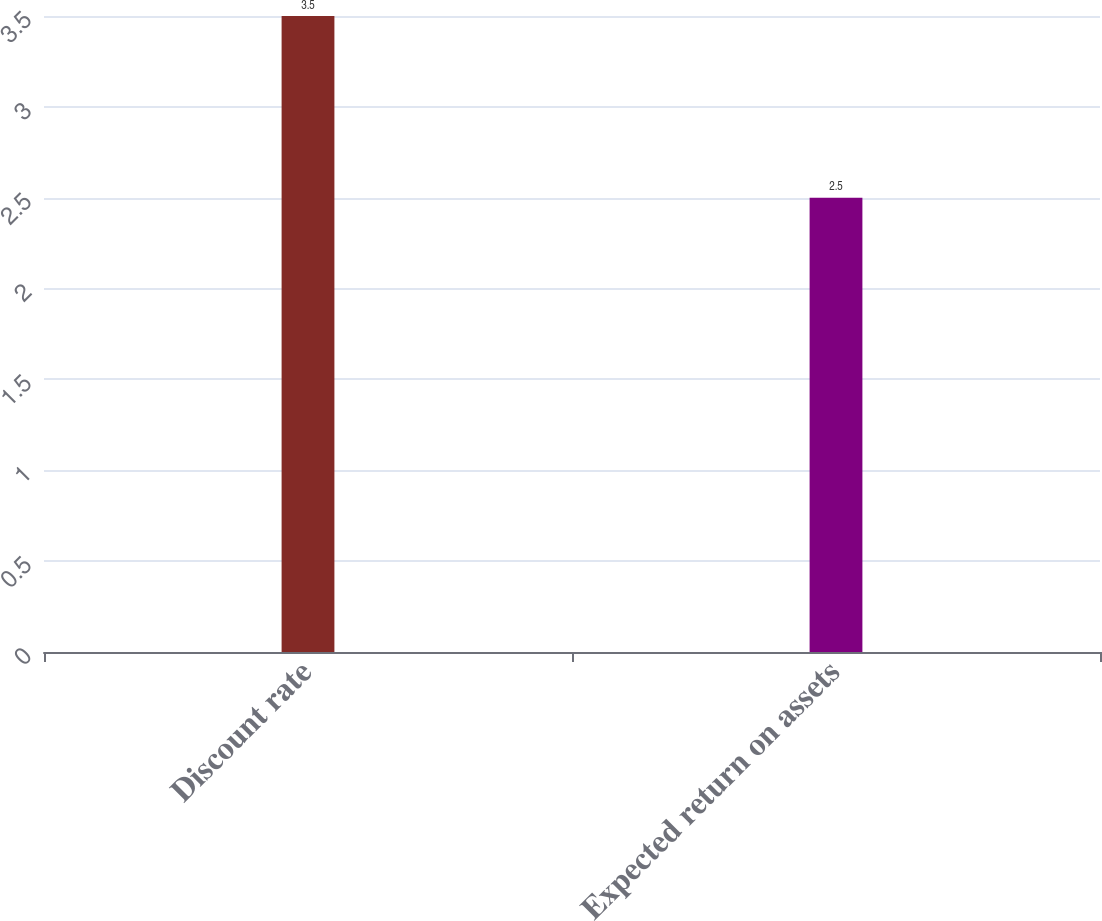Convert chart to OTSL. <chart><loc_0><loc_0><loc_500><loc_500><bar_chart><fcel>Discount rate<fcel>Expected return on assets<nl><fcel>3.5<fcel>2.5<nl></chart> 